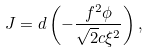Convert formula to latex. <formula><loc_0><loc_0><loc_500><loc_500>J = d \left ( - { \frac { f ^ { 2 } \phi } { \sqrt { 2 } c \xi ^ { 2 } } } \right ) ,</formula> 